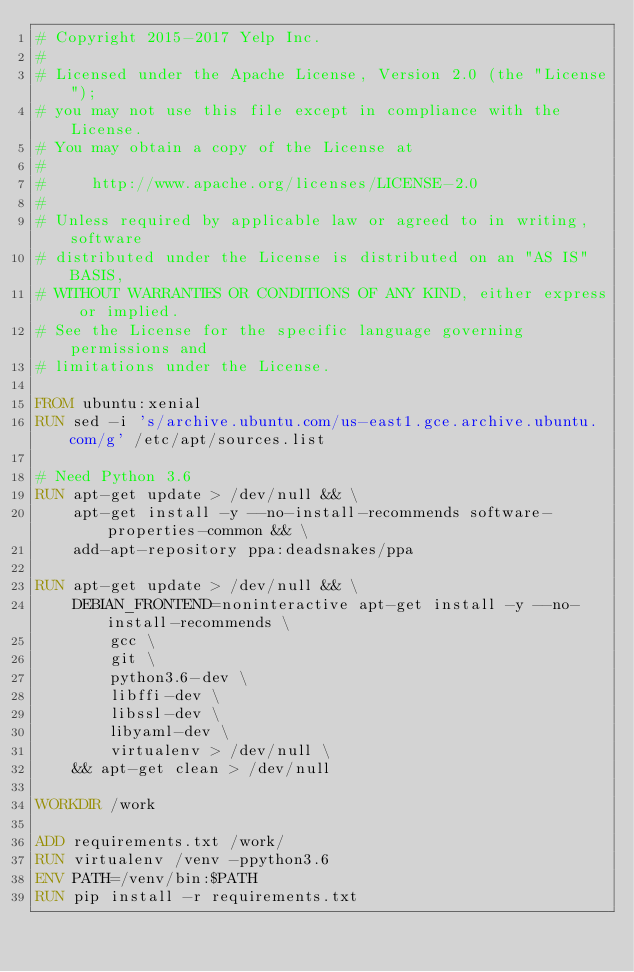Convert code to text. <code><loc_0><loc_0><loc_500><loc_500><_Dockerfile_># Copyright 2015-2017 Yelp Inc.
#
# Licensed under the Apache License, Version 2.0 (the "License");
# you may not use this file except in compliance with the License.
# You may obtain a copy of the License at
#
#     http://www.apache.org/licenses/LICENSE-2.0
#
# Unless required by applicable law or agreed to in writing, software
# distributed under the License is distributed on an "AS IS" BASIS,
# WITHOUT WARRANTIES OR CONDITIONS OF ANY KIND, either express or implied.
# See the License for the specific language governing permissions and
# limitations under the License.

FROM ubuntu:xenial
RUN sed -i 's/archive.ubuntu.com/us-east1.gce.archive.ubuntu.com/g' /etc/apt/sources.list

# Need Python 3.6
RUN apt-get update > /dev/null && \
    apt-get install -y --no-install-recommends software-properties-common && \
    add-apt-repository ppa:deadsnakes/ppa

RUN apt-get update > /dev/null && \
    DEBIAN_FRONTEND=noninteractive apt-get install -y --no-install-recommends \
        gcc \
        git \
        python3.6-dev \
        libffi-dev \
        libssl-dev \
        libyaml-dev \
        virtualenv > /dev/null \
    && apt-get clean > /dev/null

WORKDIR /work

ADD requirements.txt /work/
RUN virtualenv /venv -ppython3.6
ENV PATH=/venv/bin:$PATH
RUN pip install -r requirements.txt
</code> 